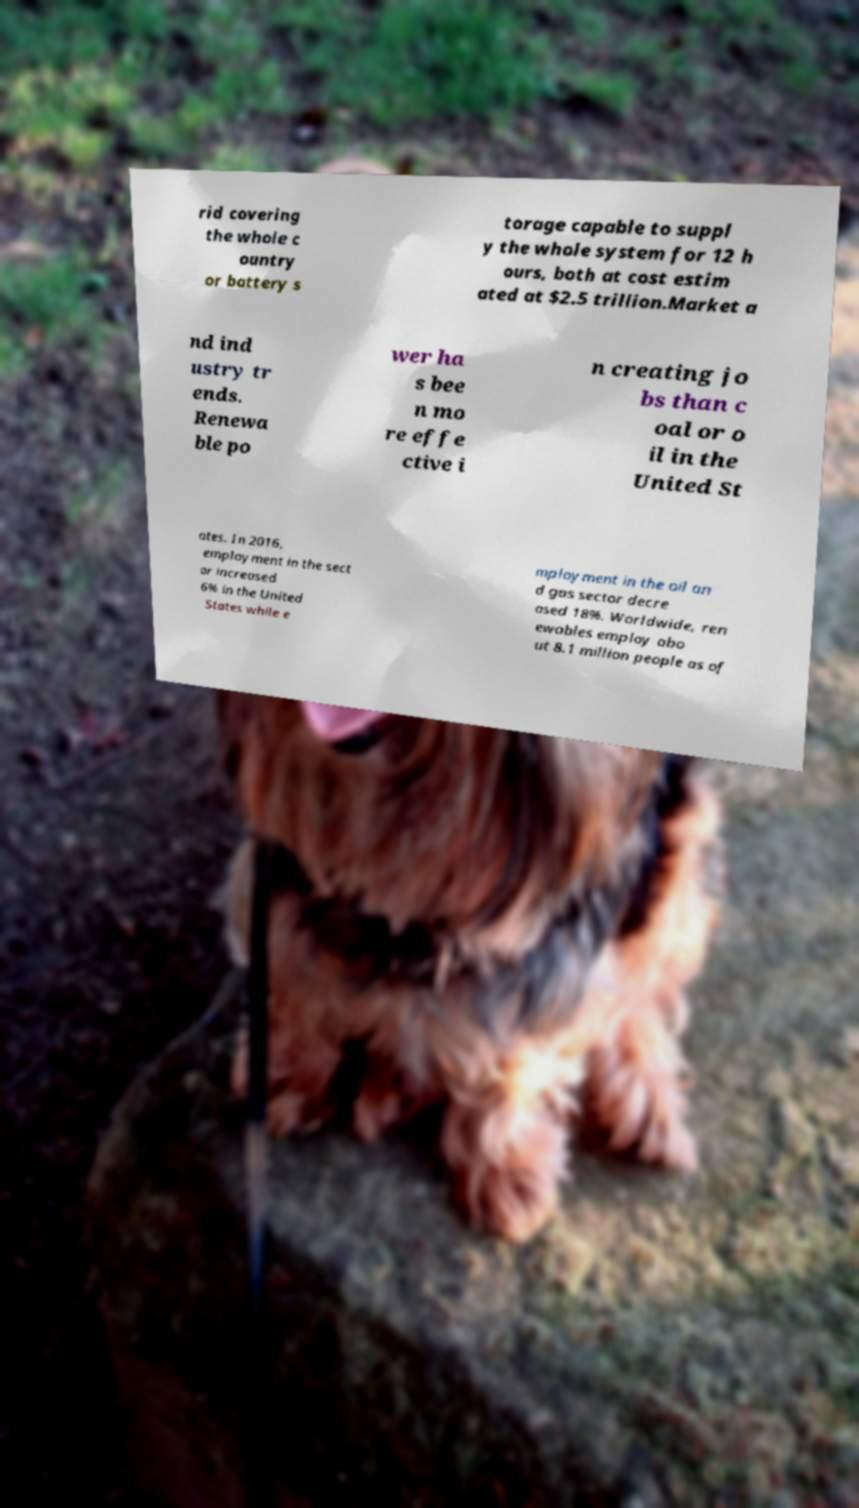Please identify and transcribe the text found in this image. rid covering the whole c ountry or battery s torage capable to suppl y the whole system for 12 h ours, both at cost estim ated at $2.5 trillion.Market a nd ind ustry tr ends. Renewa ble po wer ha s bee n mo re effe ctive i n creating jo bs than c oal or o il in the United St ates. In 2016, employment in the sect or increased 6% in the United States while e mployment in the oil an d gas sector decre ased 18%. Worldwide, ren ewables employ abo ut 8.1 million people as of 